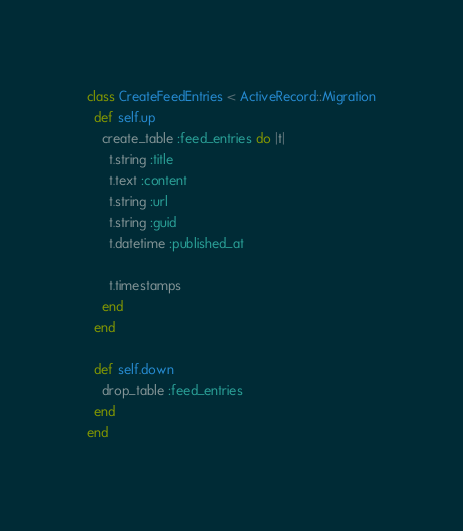<code> <loc_0><loc_0><loc_500><loc_500><_Ruby_>class CreateFeedEntries < ActiveRecord::Migration
  def self.up
    create_table :feed_entries do |t|
      t.string :title
      t.text :content
      t.string :url
      t.string :guid
      t.datetime :published_at

      t.timestamps
    end
  end

  def self.down
    drop_table :feed_entries
  end
end
</code> 